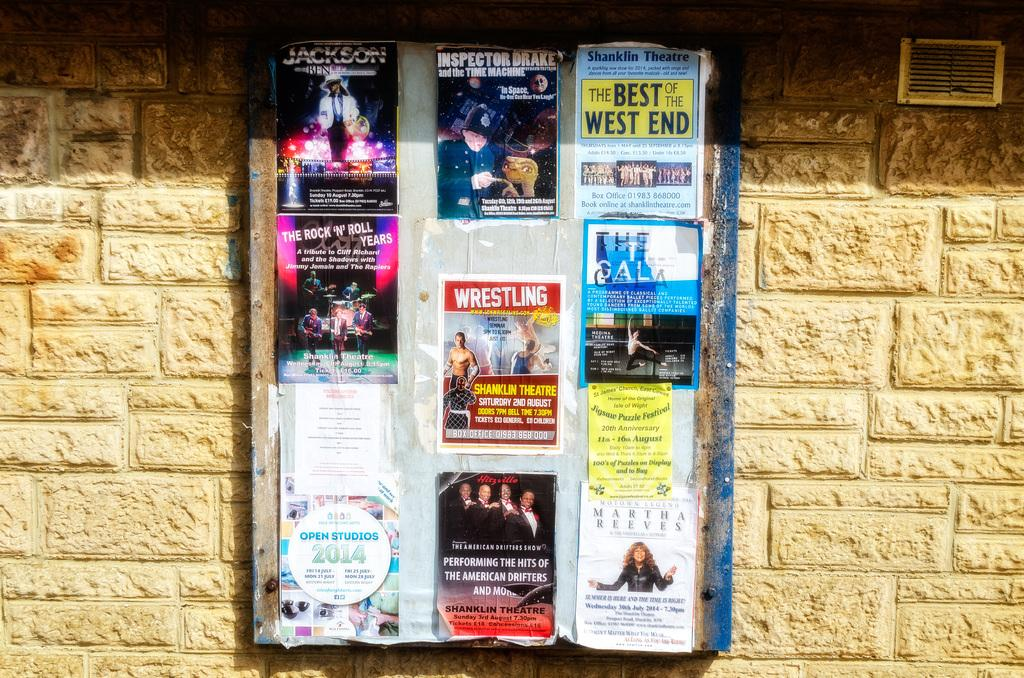<image>
Provide a brief description of the given image. A bulletin board with posters for shows like Jackson and Inspector Drake. 